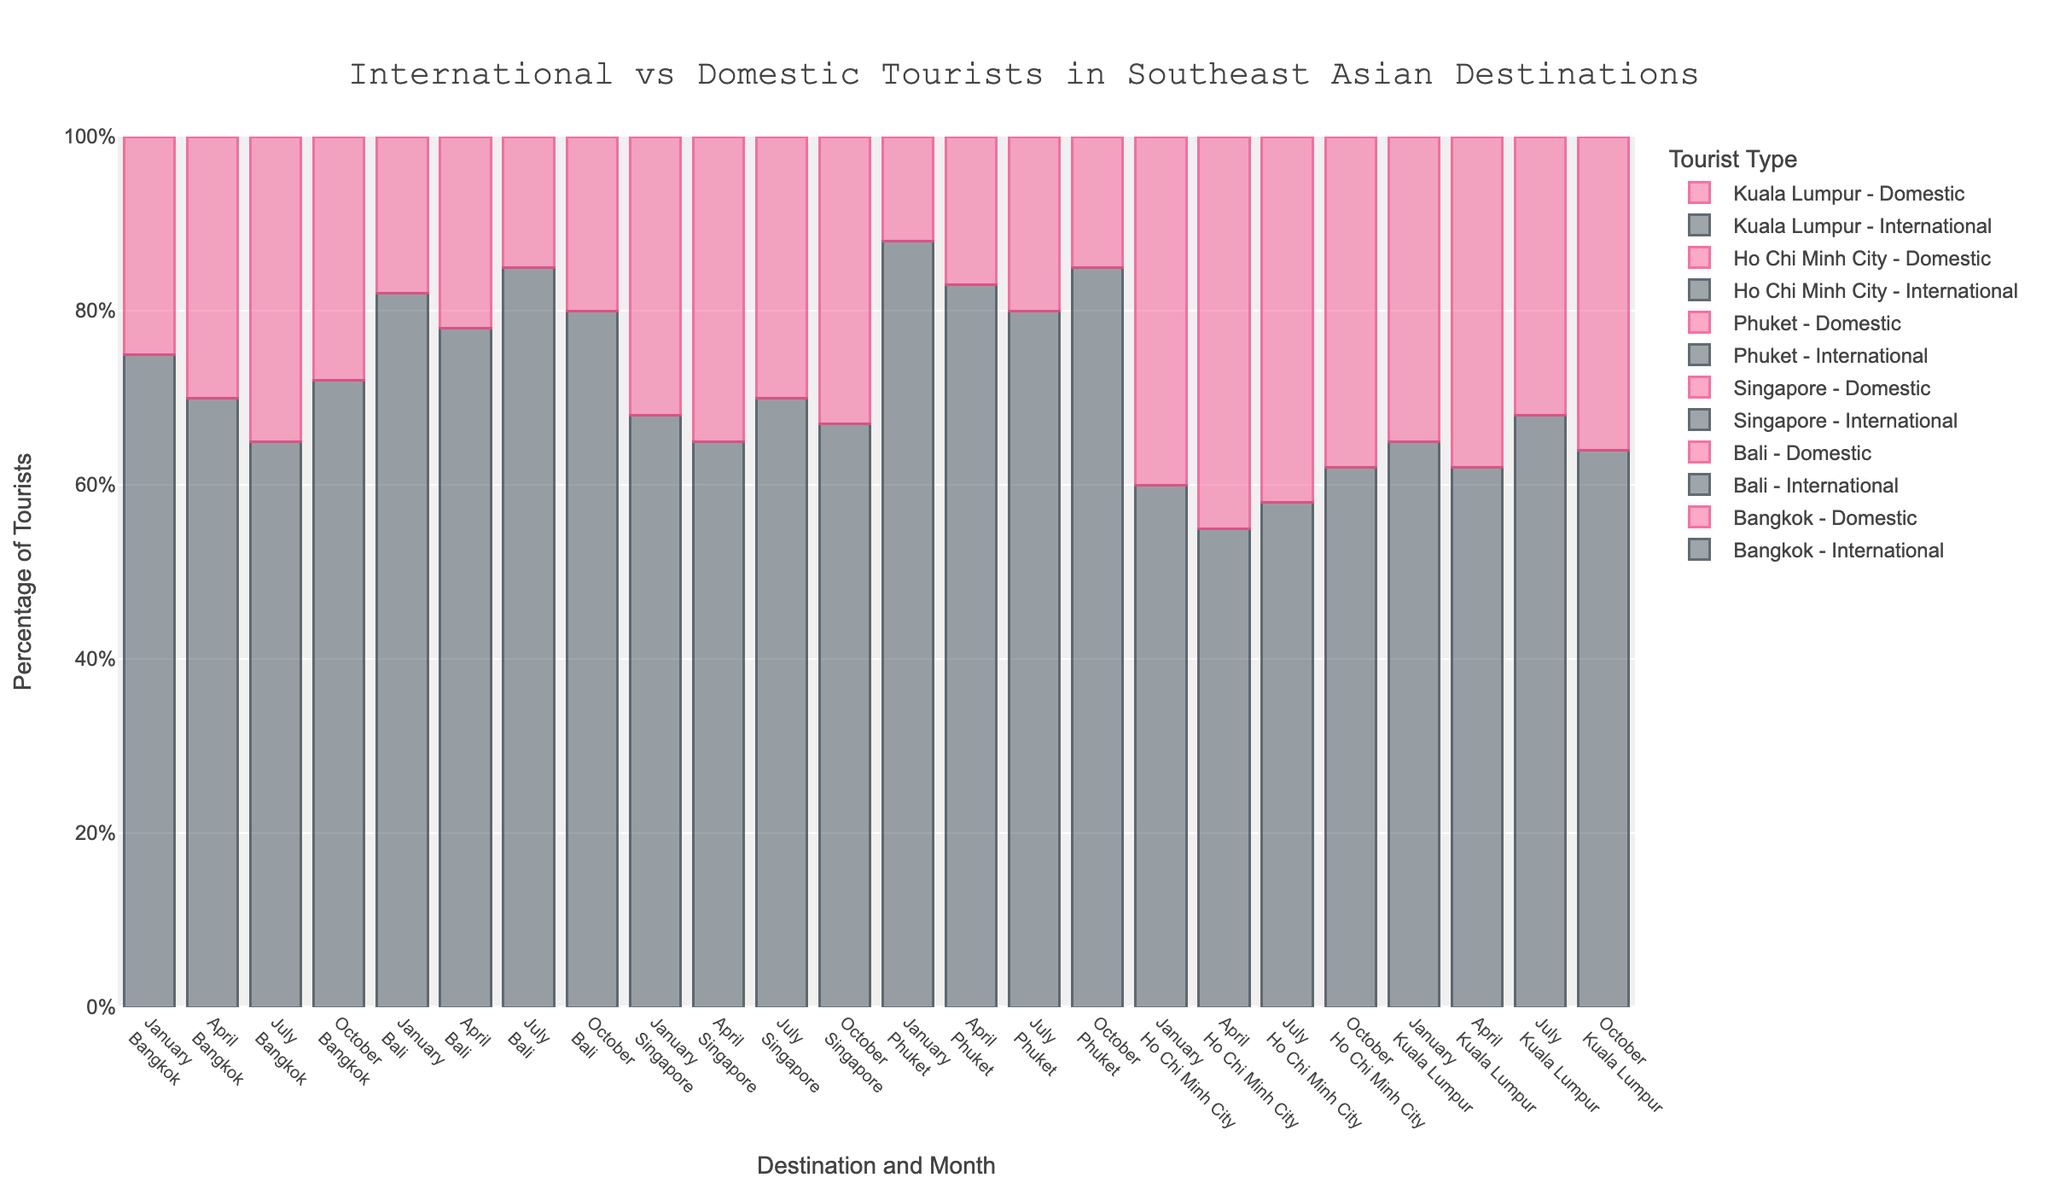Which destination has the highest percentage of international tourists in January? Calculate the percentage of international tourists for each destination in January. The values are Bangkok: 75%, Bali: 82%, Singapore: 68%, Phuket: 88%, Ho Chi Minh City: 60%, Kuala Lumpur: 65%. Phuket has the highest percentage at 88%.
Answer: Phuket Which destination has the highest percentage of domestic tourists in July? Calculate the percentage of domestic tourists for each destination in July. The values are Bangkok: 35%, Bali: 15%, Singapore: 30%, Phuket: 20%, Ho Chi Minh City: 42%, Kuala Lumpur: 32%. Ho Chi Minh City has the highest percentage at 42%.
Answer: Ho Chi Minh City What is the total percentage of international tourists in Bali across all months? Sum up the international tourist percentages in Bali for January, April, July, and October. The values are 82%, 78%, 85%, 80%. The total is 82 + 78 + 85 + 80 = 325.
Answer: 325% Which month has the lowest percentage of international tourists for Ho Chi Minh City? Compare the international tourist percentages in Ho Chi Minh City across January (60%), April (55%), July (58%), and October (62%). April has the lowest percentage at 55%.
Answer: April Compare the percentage difference of domestic tourists between Phuket and Bali in October. Subtract the domestic tourist percentage of Bali from Phuket in October. Phuket has 15% domestic tourists, while Bali has 20%. The difference is 15 - 20 = -5.
Answer: -5% Which destination shows an increasing trend of international tourists from January to October? Check the percentage change of international tourists for each destination from January to October. Bangkok goes from 75% to 72%, Bali from 82% to 80%, Singapore from 68% to 67%, Phuket from 88% to 85%, Ho Chi Minh City from 60% to 62%, Kuala Lumpur from 65% to 64%. Only Ho Chi Minh City shows an increasing trend.
Answer: Ho Chi Minh City What is the average percentage of domestic tourists in Singapore for the recorded months? Calculate the average by summing the domestic tourist percentages in Singapore for January (32%), April (35%), July (30%), and October (33%) and dividing by 4. The total is 32 + 35 + 30 + 33 = 130. The average is 130 / 4 = 32.5%.
Answer: 32.5% How does the percentage of international tourists in Bangkok in July compare to April? Subtract the percentage of international tourists in Bangkok in July (65%) from April (70%). The difference is 70 - 65 = 5%. Bangkok had a higher percentage of international tourists in April by 5%.
Answer: 5% What is the difference in the percentage of international tourists between October and January for Kuala Lumpur? Compare the percentage of international tourists in Kuala Lumpur in October (64%) and January (65%). The difference is 65 - 64 = 1%.
Answer: 1% Which month and destination combination has the closest percentage of international and domestic tourists? Compare the difference between international and domestic percentages across all months and destinations. The smallest difference is in Ho Chi Minh City in April, with 55% international and 45% domestic, giving a difference of 10%.
Answer: Ho Chi Minh City, April 